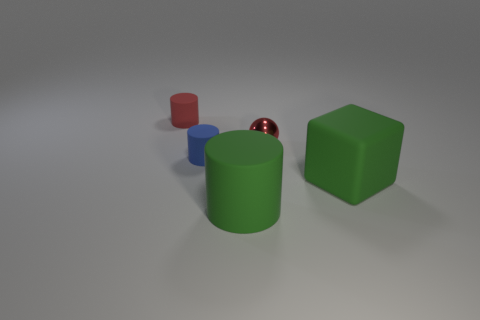Does the green cube have the same material as the sphere?
Offer a terse response. No. What number of small things are either green matte cubes or red matte objects?
Make the answer very short. 1. Is there anything else that is the same shape as the tiny blue object?
Offer a terse response. Yes. Is there anything else that has the same size as the red metallic ball?
Give a very brief answer. Yes. The big block that is the same material as the tiny blue object is what color?
Make the answer very short. Green. The rubber cylinder that is in front of the block is what color?
Make the answer very short. Green. How many metallic spheres are the same color as the block?
Your answer should be compact. 0. Is the number of red metallic objects that are in front of the large green rubber block less than the number of red rubber objects left of the big matte cylinder?
Keep it short and to the point. Yes. What number of blue cylinders are on the left side of the small blue cylinder?
Keep it short and to the point. 0. Is there a small red thing made of the same material as the big block?
Provide a succinct answer. Yes. 